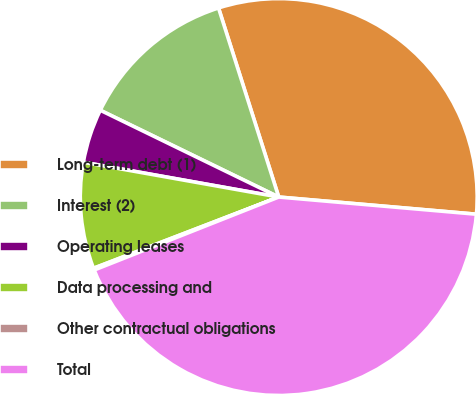<chart> <loc_0><loc_0><loc_500><loc_500><pie_chart><fcel>Long-term debt (1)<fcel>Interest (2)<fcel>Operating leases<fcel>Data processing and<fcel>Other contractual obligations<fcel>Total<nl><fcel>31.29%<fcel>12.89%<fcel>4.4%<fcel>8.65%<fcel>0.15%<fcel>42.63%<nl></chart> 